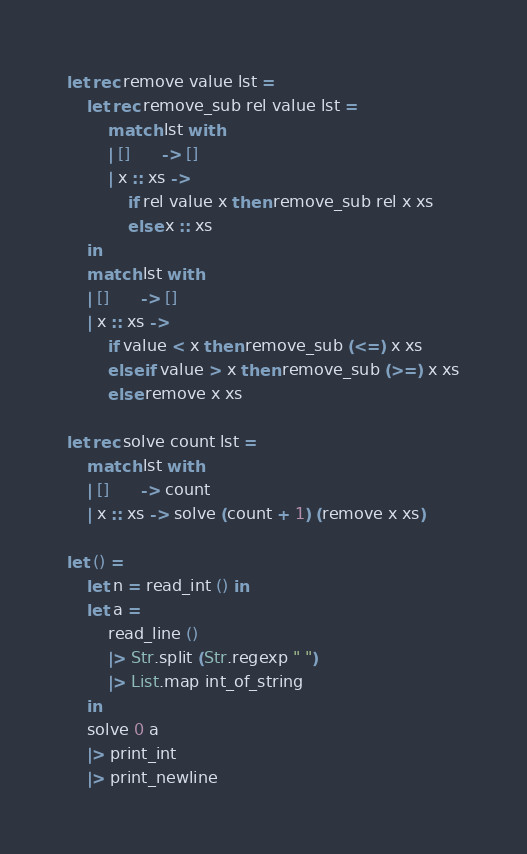Convert code to text. <code><loc_0><loc_0><loc_500><loc_500><_OCaml_>let rec remove value lst =
	let rec remove_sub rel value lst =
		match lst with
		| []      -> []
		| x :: xs ->
			if rel value x then remove_sub rel x xs
			else x :: xs
	in
	match lst with
	| []      -> []
	| x :: xs ->
		if value < x then remove_sub (<=) x xs
		else if value > x then remove_sub (>=) x xs
		else remove x xs

let rec solve count lst =
	match lst with
	| []      -> count
	| x :: xs -> solve (count + 1) (remove x xs)

let () =
	let n = read_int () in
	let a =
		read_line ()
		|> Str.split (Str.regexp " ")
		|> List.map int_of_string
	in
	solve 0 a
	|> print_int
	|> print_newline
</code> 